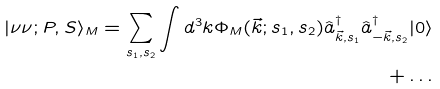<formula> <loc_0><loc_0><loc_500><loc_500>| \nu \nu ; P , S \rangle _ { M } = \sum _ { s _ { 1 } , s _ { 2 } } \int d ^ { 3 } k \Phi _ { M } ( \vec { k } ; s _ { 1 } , s _ { 2 } ) \hat { a } ^ { \dag } _ { \vec { k } , s _ { 1 } } \hat { a } ^ { \dag } _ { - \vec { k } , s _ { 2 } } | 0 \rangle \\ + \dots</formula> 